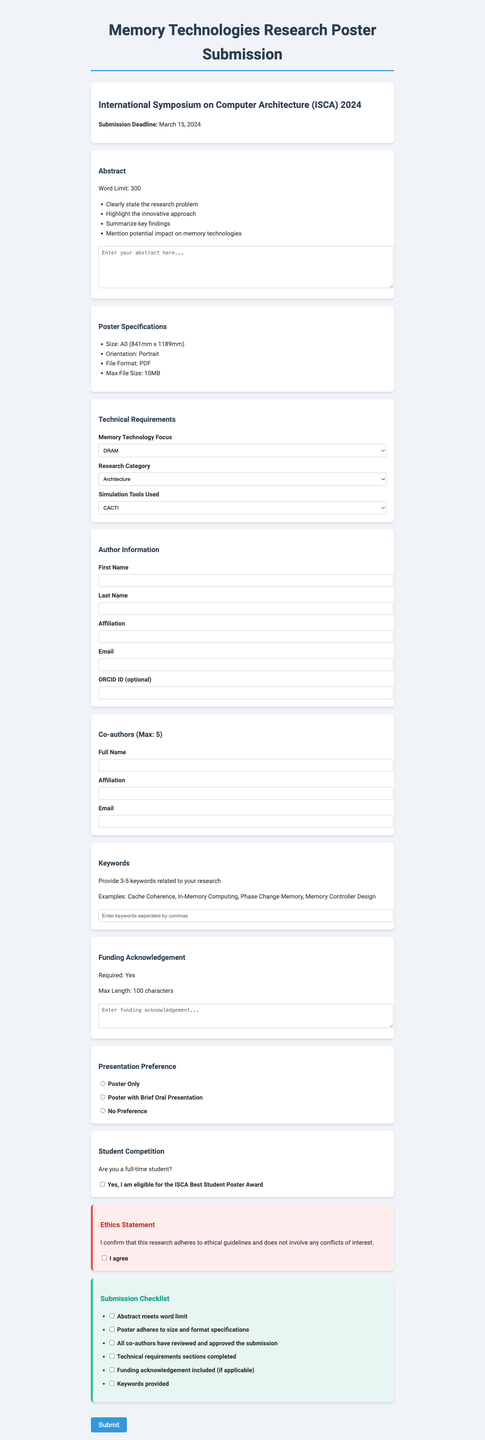what is the submission deadline? The submission deadline for the poster is clearly stated in the document.
Answer: March 15, 2024 what is the maximum file size for the poster? The document specifies the maximum file size allowed for the poster submission.
Answer: 10MB how many keywords should be provided? The document instructs the author to provide a specific range of keywords related to their research.
Answer: 3-5 keywords what is one required aspect of the abstract content? The document lists specific guidelines that must be followed when writing the abstract.
Answer: Clearly state the research problem how many co-authors can be listed? The document limits the number of co-authors that can be included in the submission.
Answer: 5 what is the focus of the technical requirements? The document outlines a specific area related to memory technologies that submissions need to address.
Answer: Memory Technology Focus which ethical requirement must be confirmed? The document includes a statement regarding adherence to ethical guidelines that must be acknowledged.
Answer: Research adheres to ethical guidelines what is one option for presentation preference? The document lists different ways in which the submission can be presented during the conference.
Answer: Poster with Brief Oral Presentation 